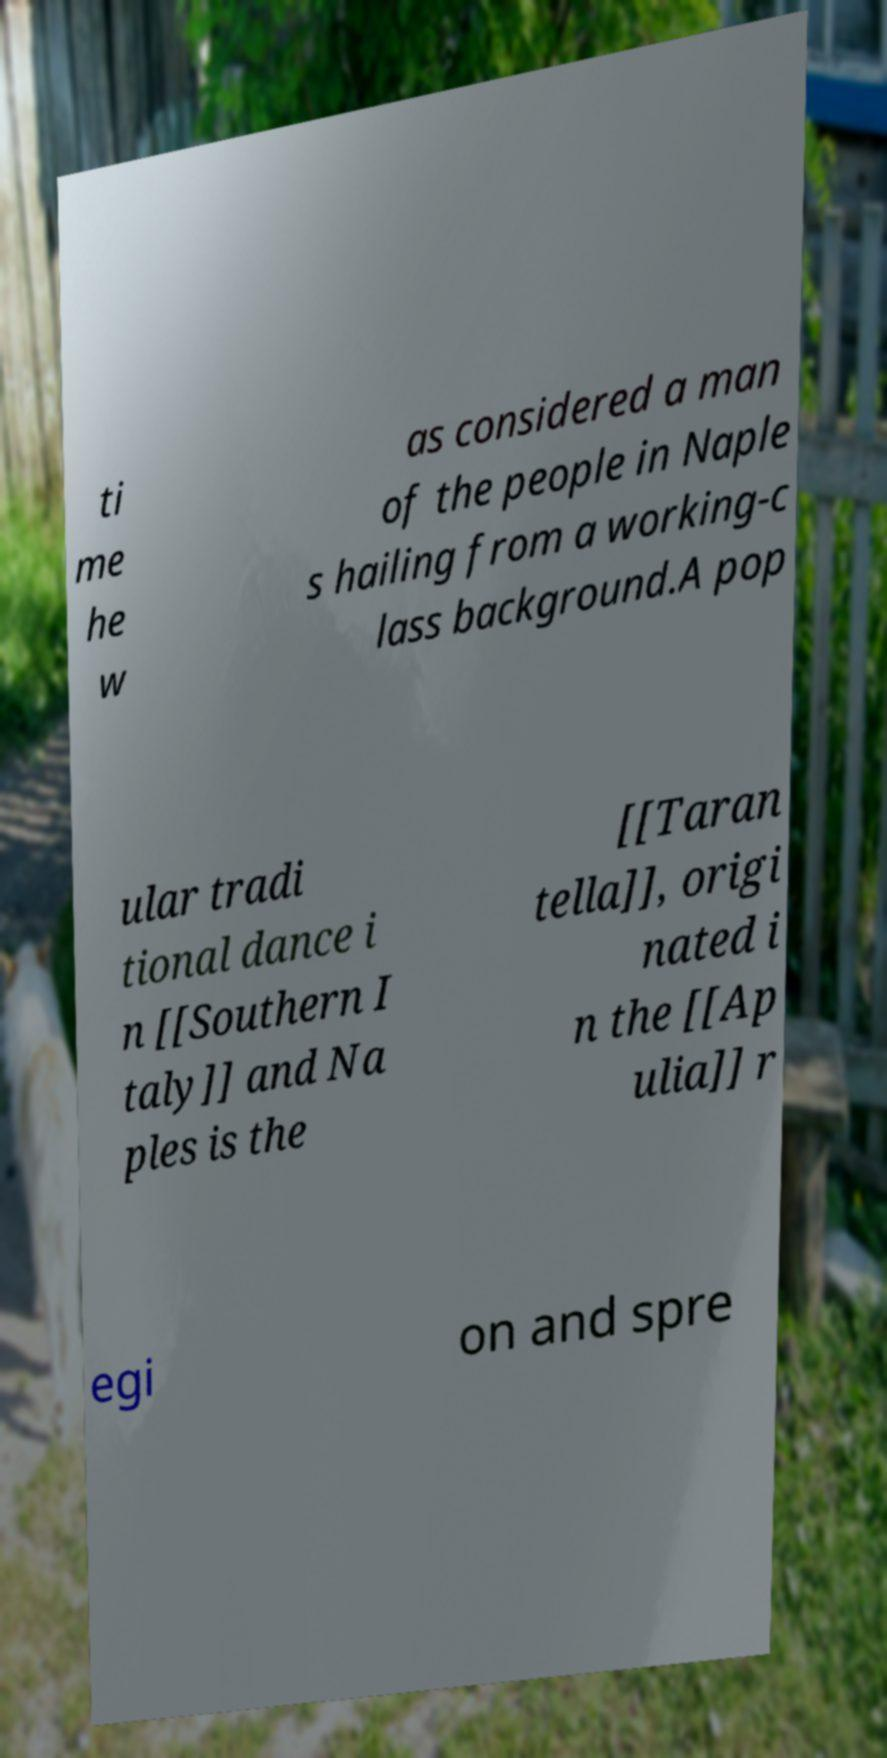Can you accurately transcribe the text from the provided image for me? ti me he w as considered a man of the people in Naple s hailing from a working-c lass background.A pop ular tradi tional dance i n [[Southern I taly]] and Na ples is the [[Taran tella]], origi nated i n the [[Ap ulia]] r egi on and spre 